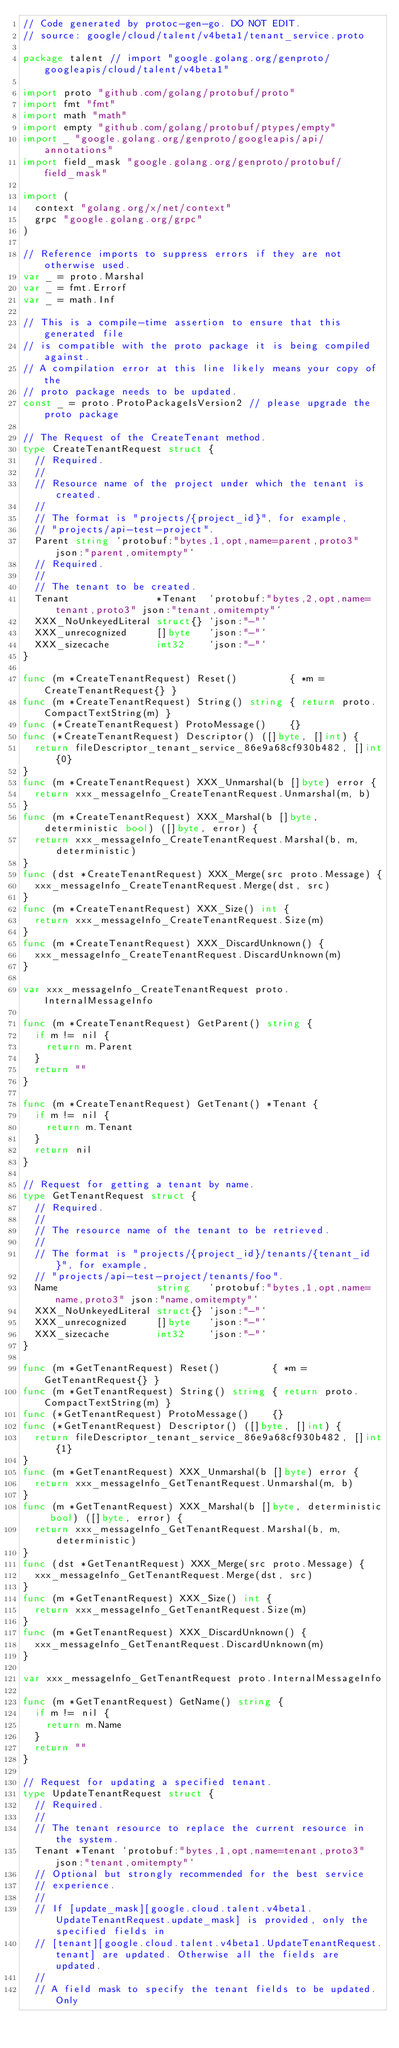<code> <loc_0><loc_0><loc_500><loc_500><_Go_>// Code generated by protoc-gen-go. DO NOT EDIT.
// source: google/cloud/talent/v4beta1/tenant_service.proto

package talent // import "google.golang.org/genproto/googleapis/cloud/talent/v4beta1"

import proto "github.com/golang/protobuf/proto"
import fmt "fmt"
import math "math"
import empty "github.com/golang/protobuf/ptypes/empty"
import _ "google.golang.org/genproto/googleapis/api/annotations"
import field_mask "google.golang.org/genproto/protobuf/field_mask"

import (
	context "golang.org/x/net/context"
	grpc "google.golang.org/grpc"
)

// Reference imports to suppress errors if they are not otherwise used.
var _ = proto.Marshal
var _ = fmt.Errorf
var _ = math.Inf

// This is a compile-time assertion to ensure that this generated file
// is compatible with the proto package it is being compiled against.
// A compilation error at this line likely means your copy of the
// proto package needs to be updated.
const _ = proto.ProtoPackageIsVersion2 // please upgrade the proto package

// The Request of the CreateTenant method.
type CreateTenantRequest struct {
	// Required.
	//
	// Resource name of the project under which the tenant is created.
	//
	// The format is "projects/{project_id}", for example,
	// "projects/api-test-project".
	Parent string `protobuf:"bytes,1,opt,name=parent,proto3" json:"parent,omitempty"`
	// Required.
	//
	// The tenant to be created.
	Tenant               *Tenant  `protobuf:"bytes,2,opt,name=tenant,proto3" json:"tenant,omitempty"`
	XXX_NoUnkeyedLiteral struct{} `json:"-"`
	XXX_unrecognized     []byte   `json:"-"`
	XXX_sizecache        int32    `json:"-"`
}

func (m *CreateTenantRequest) Reset()         { *m = CreateTenantRequest{} }
func (m *CreateTenantRequest) String() string { return proto.CompactTextString(m) }
func (*CreateTenantRequest) ProtoMessage()    {}
func (*CreateTenantRequest) Descriptor() ([]byte, []int) {
	return fileDescriptor_tenant_service_86e9a68cf930b482, []int{0}
}
func (m *CreateTenantRequest) XXX_Unmarshal(b []byte) error {
	return xxx_messageInfo_CreateTenantRequest.Unmarshal(m, b)
}
func (m *CreateTenantRequest) XXX_Marshal(b []byte, deterministic bool) ([]byte, error) {
	return xxx_messageInfo_CreateTenantRequest.Marshal(b, m, deterministic)
}
func (dst *CreateTenantRequest) XXX_Merge(src proto.Message) {
	xxx_messageInfo_CreateTenantRequest.Merge(dst, src)
}
func (m *CreateTenantRequest) XXX_Size() int {
	return xxx_messageInfo_CreateTenantRequest.Size(m)
}
func (m *CreateTenantRequest) XXX_DiscardUnknown() {
	xxx_messageInfo_CreateTenantRequest.DiscardUnknown(m)
}

var xxx_messageInfo_CreateTenantRequest proto.InternalMessageInfo

func (m *CreateTenantRequest) GetParent() string {
	if m != nil {
		return m.Parent
	}
	return ""
}

func (m *CreateTenantRequest) GetTenant() *Tenant {
	if m != nil {
		return m.Tenant
	}
	return nil
}

// Request for getting a tenant by name.
type GetTenantRequest struct {
	// Required.
	//
	// The resource name of the tenant to be retrieved.
	//
	// The format is "projects/{project_id}/tenants/{tenant_id}", for example,
	// "projects/api-test-project/tenants/foo".
	Name                 string   `protobuf:"bytes,1,opt,name=name,proto3" json:"name,omitempty"`
	XXX_NoUnkeyedLiteral struct{} `json:"-"`
	XXX_unrecognized     []byte   `json:"-"`
	XXX_sizecache        int32    `json:"-"`
}

func (m *GetTenantRequest) Reset()         { *m = GetTenantRequest{} }
func (m *GetTenantRequest) String() string { return proto.CompactTextString(m) }
func (*GetTenantRequest) ProtoMessage()    {}
func (*GetTenantRequest) Descriptor() ([]byte, []int) {
	return fileDescriptor_tenant_service_86e9a68cf930b482, []int{1}
}
func (m *GetTenantRequest) XXX_Unmarshal(b []byte) error {
	return xxx_messageInfo_GetTenantRequest.Unmarshal(m, b)
}
func (m *GetTenantRequest) XXX_Marshal(b []byte, deterministic bool) ([]byte, error) {
	return xxx_messageInfo_GetTenantRequest.Marshal(b, m, deterministic)
}
func (dst *GetTenantRequest) XXX_Merge(src proto.Message) {
	xxx_messageInfo_GetTenantRequest.Merge(dst, src)
}
func (m *GetTenantRequest) XXX_Size() int {
	return xxx_messageInfo_GetTenantRequest.Size(m)
}
func (m *GetTenantRequest) XXX_DiscardUnknown() {
	xxx_messageInfo_GetTenantRequest.DiscardUnknown(m)
}

var xxx_messageInfo_GetTenantRequest proto.InternalMessageInfo

func (m *GetTenantRequest) GetName() string {
	if m != nil {
		return m.Name
	}
	return ""
}

// Request for updating a specified tenant.
type UpdateTenantRequest struct {
	// Required.
	//
	// The tenant resource to replace the current resource in the system.
	Tenant *Tenant `protobuf:"bytes,1,opt,name=tenant,proto3" json:"tenant,omitempty"`
	// Optional but strongly recommended for the best service
	// experience.
	//
	// If [update_mask][google.cloud.talent.v4beta1.UpdateTenantRequest.update_mask] is provided, only the specified fields in
	// [tenant][google.cloud.talent.v4beta1.UpdateTenantRequest.tenant] are updated. Otherwise all the fields are updated.
	//
	// A field mask to specify the tenant fields to be updated. Only</code> 